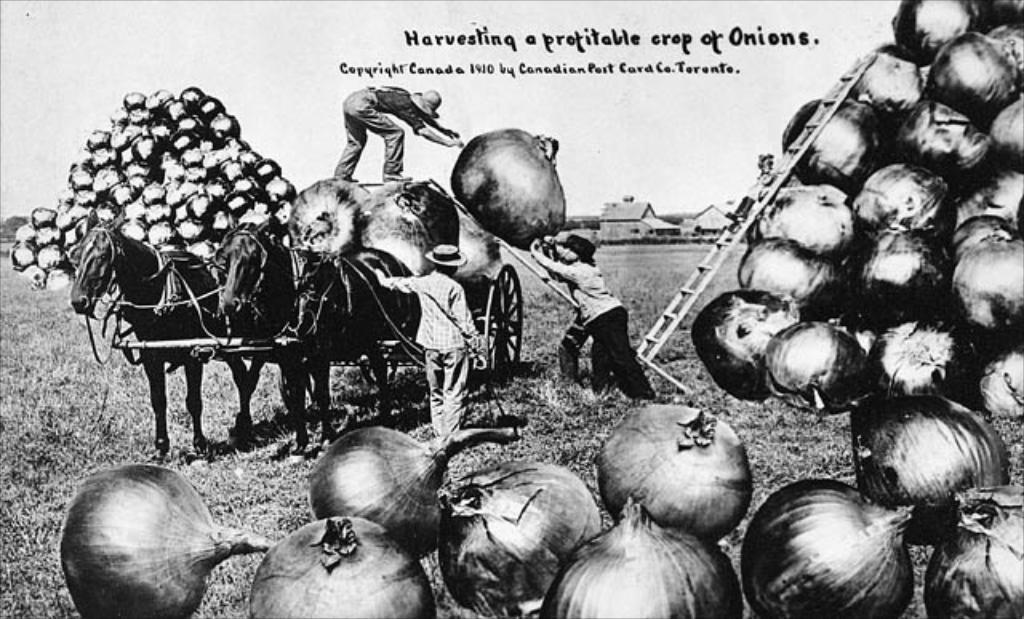Can you describe this image briefly? In this image in the front there are images of onions and in the center there are persons and there are horses. In the background there are houses and in the center, on the ground there is grass and on the top there is some text written on the image. 